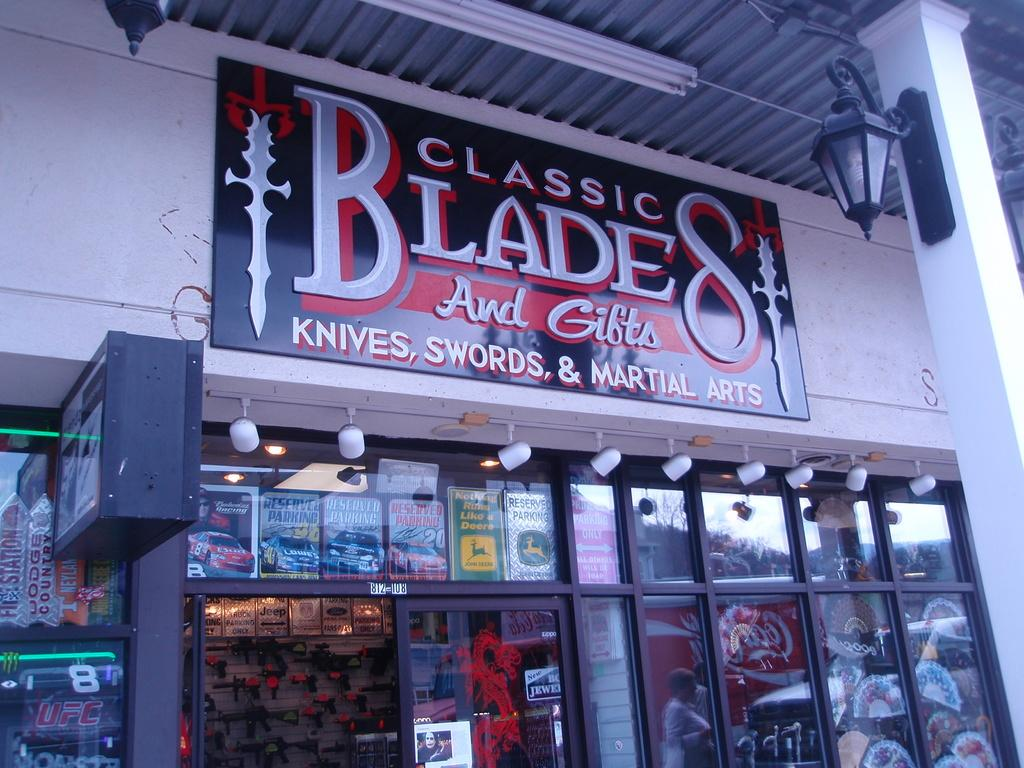<image>
Create a compact narrative representing the image presented. a store front with a sign that says Classic Blades and gifts knives, swords and martial arts on it 